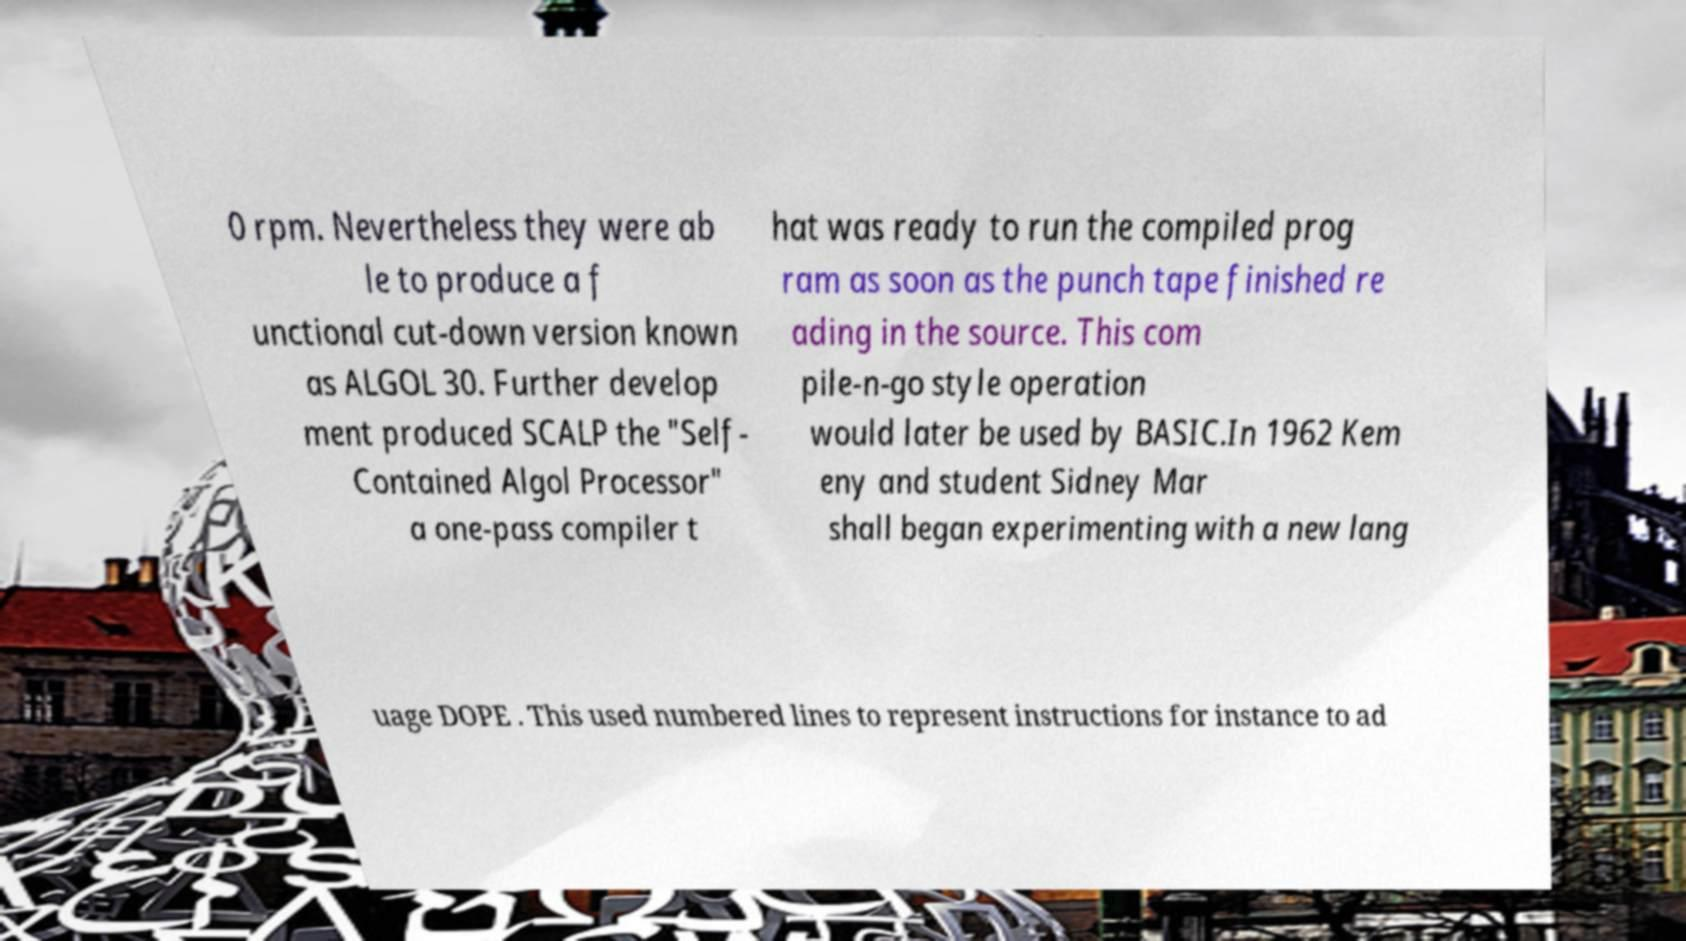For documentation purposes, I need the text within this image transcribed. Could you provide that? 0 rpm. Nevertheless they were ab le to produce a f unctional cut-down version known as ALGOL 30. Further develop ment produced SCALP the "Self- Contained Algol Processor" a one-pass compiler t hat was ready to run the compiled prog ram as soon as the punch tape finished re ading in the source. This com pile-n-go style operation would later be used by BASIC.In 1962 Kem eny and student Sidney Mar shall began experimenting with a new lang uage DOPE . This used numbered lines to represent instructions for instance to ad 